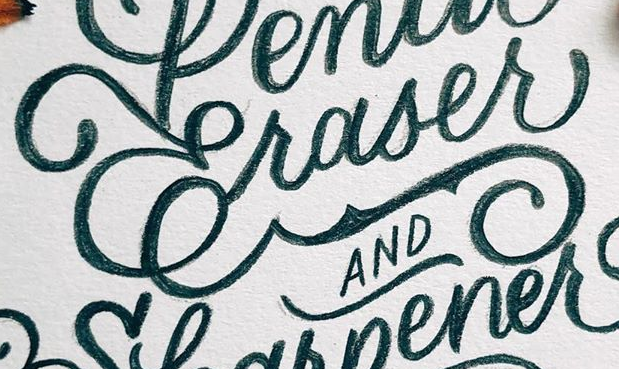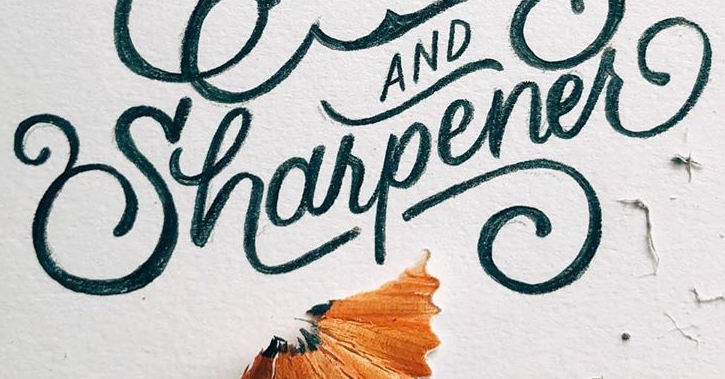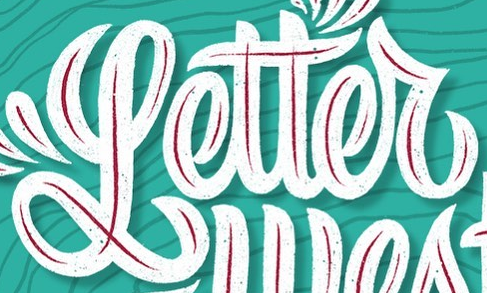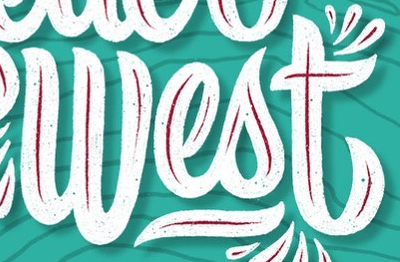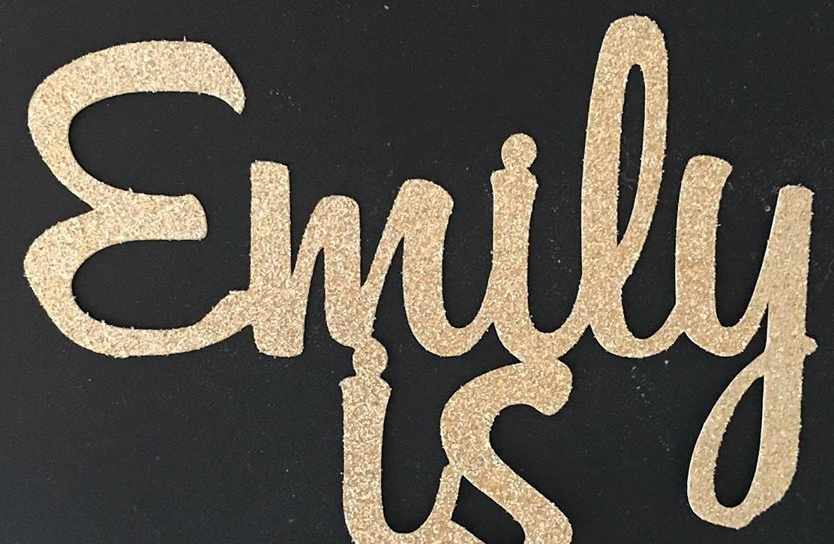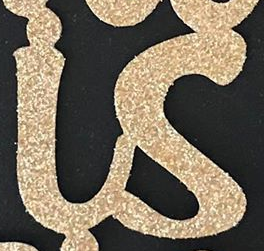Read the text from these images in sequence, separated by a semicolon. Craser; Uharpener; Letter; West; Emily; is 